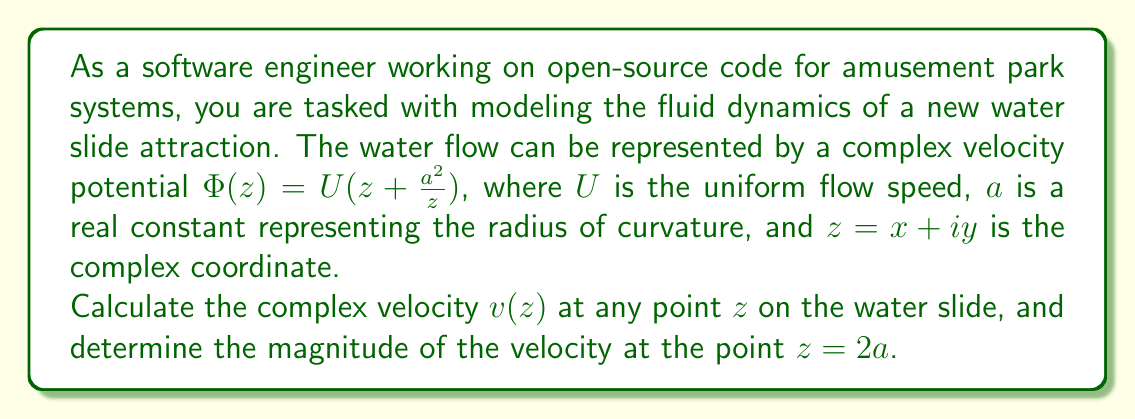What is the answer to this math problem? To solve this problem, we'll follow these steps:

1) The complex velocity $v(z)$ is given by the derivative of the complex potential $\Phi(z)$:

   $$v(z) = \frac{d\Phi}{dz} = \Phi'(z)$$

2) Let's differentiate $\Phi(z)$ with respect to $z$:

   $$\Phi(z) = U(z + \frac{a^2}{z})$$
   $$\Phi'(z) = U(1 - \frac{a^2}{z^2})$$

3) Therefore, the complex velocity at any point $z$ is:

   $$v(z) = U(1 - \frac{a^2}{z^2})$$

4) To find the magnitude of the velocity at $z = 2a$, we substitute this value into our expression for $v(z)$:

   $$v(2a) = U(1 - \frac{a^2}{(2a)^2}) = U(1 - \frac{1}{4})$$

5) The magnitude of a complex number is given by its absolute value. In this case, since the result is real, we can simply calculate:

   $$|v(2a)| = U|\frac{3}{4}| = \frac{3U}{4}$$

Thus, the magnitude of the velocity at $z = 2a$ is $\frac{3U}{4}$.
Answer: The complex velocity at any point $z$ is given by $v(z) = U(1 - \frac{a^2}{z^2})$, and the magnitude of the velocity at $z = 2a$ is $\frac{3U}{4}$. 